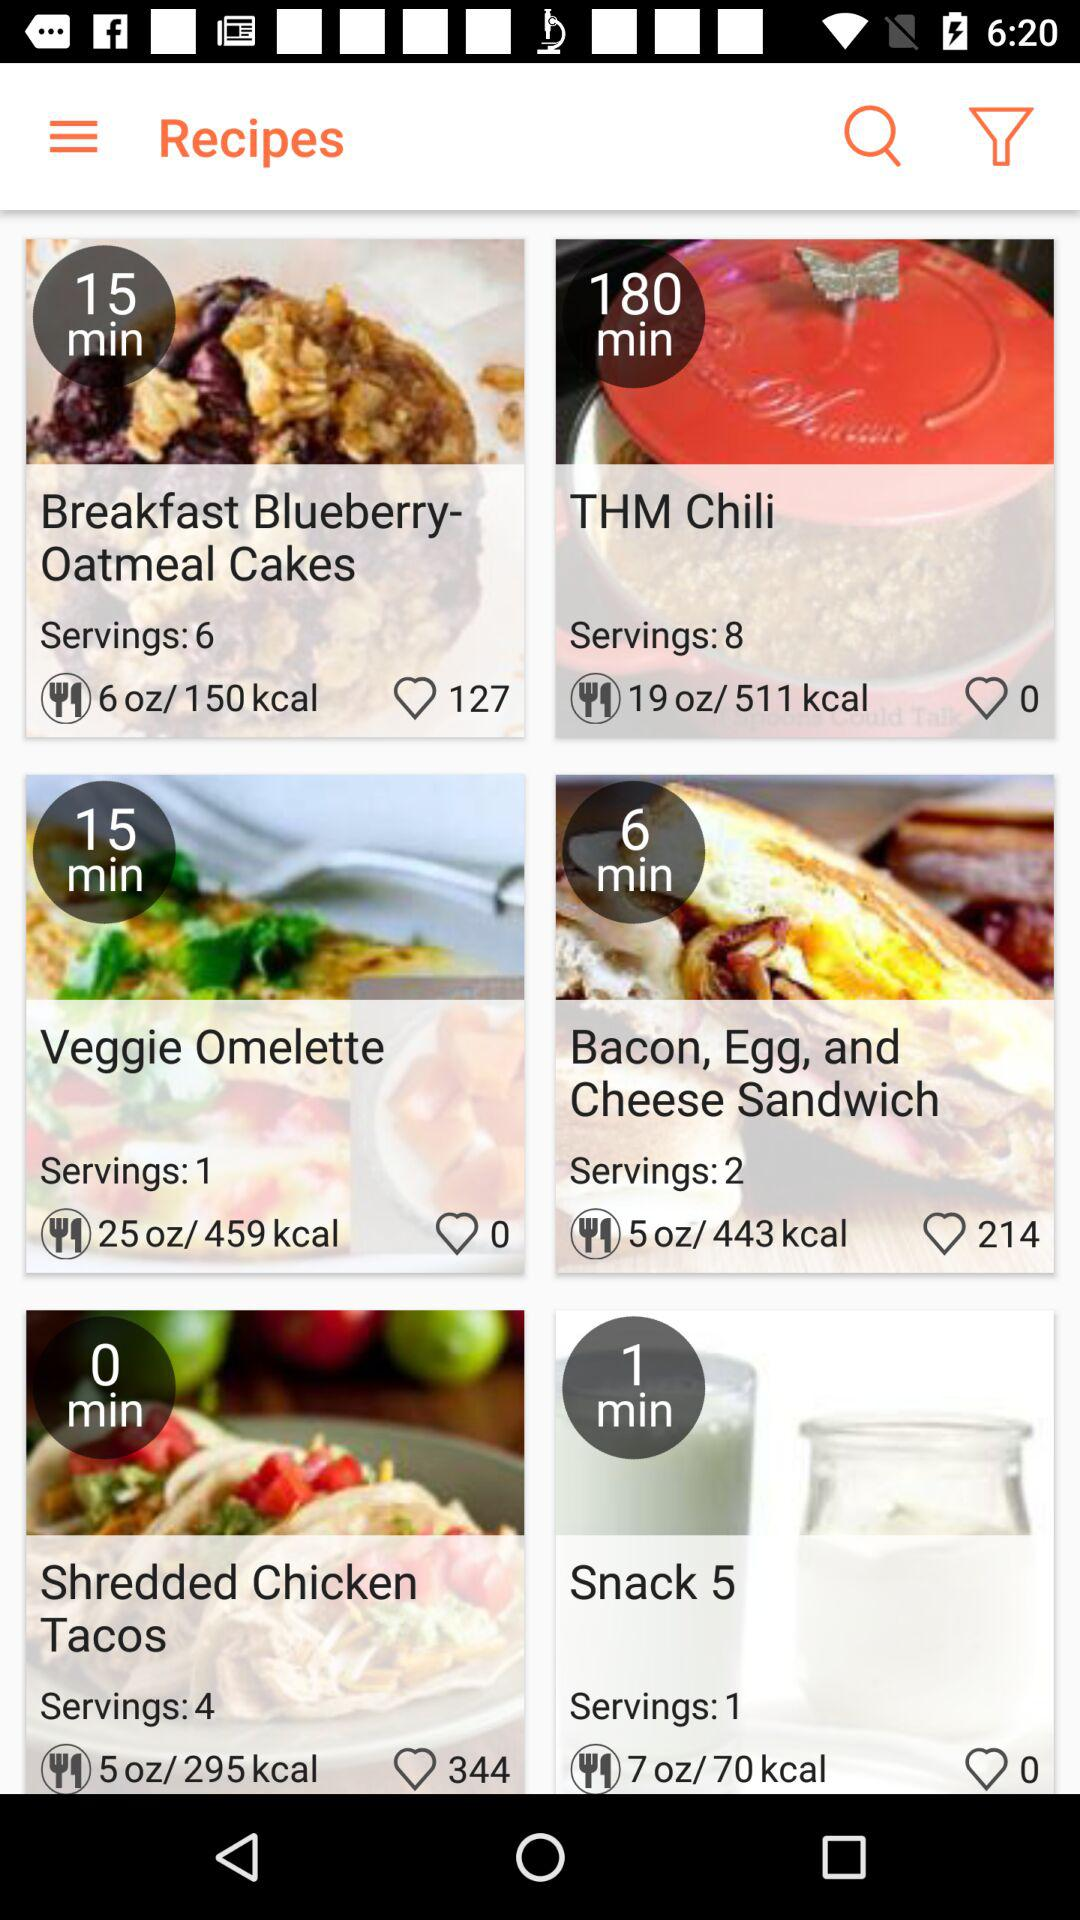How long does it take to make "THM Chili"? It takes 180 minutes to make "THM Chili". 